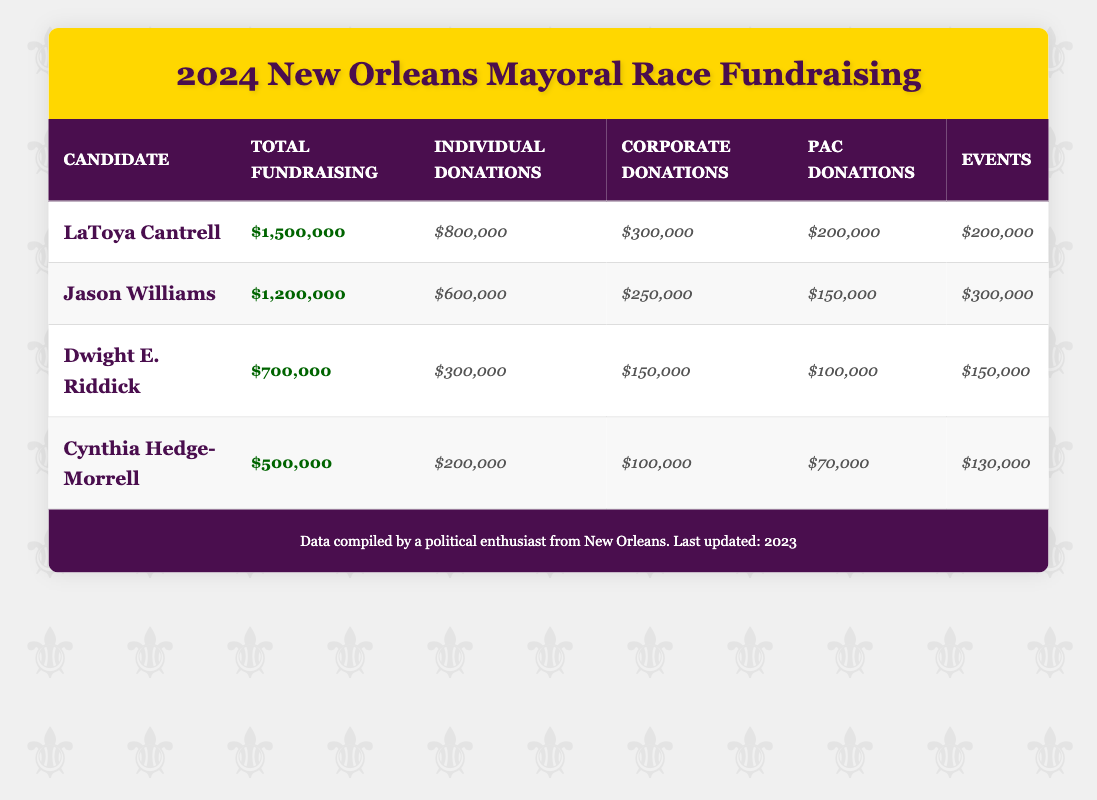What is LaToya Cantrell's total fundraising amount? The table shows that LaToya Cantrell has a total fundraising amount of $1,500,000. This value is directly listed under the "Total Fundraising" column for her row.
Answer: $1,500,000 How much did Jason Williams raise from individual donations? According to the table, Jason Williams raised $600,000 from individual donations, which is specified in his row under the "Individual Donations" column.
Answer: $600,000 Which candidate raised the least total amount in this fundraising campaign? By comparing the total fundraising amounts in the "Total Fundraising" column, Cynthia Hedge-Morrell has the lowest amount raised at $500,000. This is lower than the amounts raised by all other candidates.
Answer: Cynthia Hedge-Morrell What is the total amount raised by Dwight E. Riddick from events and PAC donations combined? To find this, add Dwight E. Riddick's fundraising amounts: Events ($150,000) + PAC Donations ($100,000) = $250,000. Therefore, the total from these two sources is $250,000.
Answer: $250,000 Did LaToya Cantrell raise more from corporate donations than Jason Williams? LaToya Cantrell raised $300,000 from corporate donations, while Jason Williams raised $250,000. Since $300,000 is greater than $250,000, the answer is yes.
Answer: Yes What is the total amount raised from all candidates combined? To find the total raised from all candidates, sum the total fundraising amounts: $1,500,000 (Cantrell) + $1,200,000 (Williams) + $700,000 (Riddick) + $500,000 (Hedge-Morrell) = $3,900,000. This gives the total amount raised by all candidates.
Answer: $3,900,000 What percentage of LaToya Cantrell's total fundraising came from individual donations? To calculate this, find the percentage: (Individual Donations / Total Fundraising) * 100. This is ($800,000 / $1,500,000) * 100 = 53.33%. Therefore, approximately 53.33% of her total fundraising came from individual donations.
Answer: 53.33% Which candidate had the highest amount raised from events, and how much was it? Looking at the "Events" column, Jason Williams raised the highest amount at $300,000. This is the maximum value listed in the events column for all candidates.
Answer: Jason Williams, $300,000 Is it true that Dwight E. Riddick received more from political action committees than Cynthia Hedge-Morrell? Dwight E. Riddick received $100,000 from political action committees, while Cynthia Hedge-Morrell received $70,000. Since $100,000 is greater than $70,000, the answer is yes.
Answer: Yes 